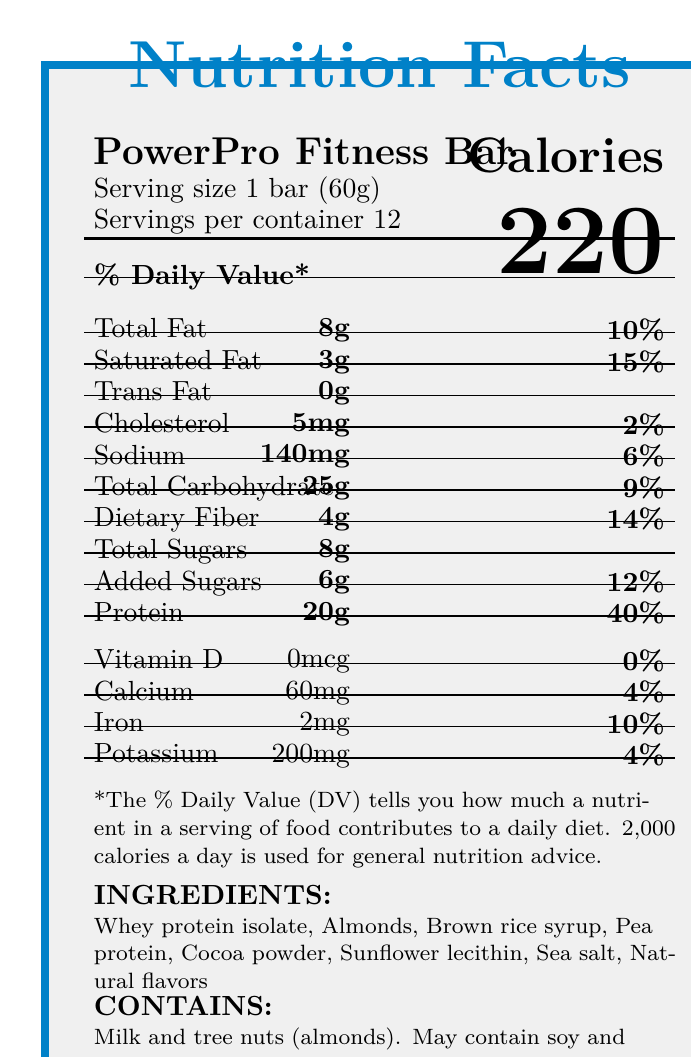what is the product name? The product name is located at the top of the document, under the title "Nutrition Facts".
Answer: PowerPro Fitness Bar how many servings are there per container? The information is found under the serving size and servings per container subheading.
Answer: 12 how many calories are in one serving? The calorie count per serving is prominently displayed on the right side of the document.
Answer: 220 what is the total amount of protein per serving? The protein content is listed in the main table under the "Protein" heading.
Answer: 20g what allergens does this product contain? The allergen information is found near the bottom under the CONTAINS section.
Answer: Milk and tree nuts (almonds) what is the daily value percentage for dietary fiber? This value is found under the "Dietary Fiber" row of the main table.
Answer: 14% what ingredients are used in this product? The ingredient list is located near the bottom of the document.
Answer: Whey protein isolate, Almonds, Brown rice syrup, Pea protein, Cocoa powder, Sunflower lecithin, Sea salt, Natural flavors does the product contain any artificial sweeteners? One of the health claims mentions that the product has "No artificial sweeteners".
Answer: No where should this product be stored? The storage instructions indicate that the product should be stored in a cool, dry place.
Answer: In a cool, dry place describe the main idea of this document. The document's main focus is to inform the consumer about the nutritional content, benefits, and storage of the PowerPro Fitness Bar.
Answer: The document provides detailed nutritional information about the PowerPro Fitness Bar, including serving size, calorie content, nutrient breakdown, ingredients, allergens, and storage instructions. what is the total carbohydrate content per serving? The total carbohydrate content is listed under "Total Carbohydrate" in the main table.
Answer: 25g what is the address of the manufacturer? The manufacturer’s address is found in the manufacturer info section.
Answer: 123 Fitness Way, Wellness City, CA 90210 which of the following is NOT an ingredient in the PowerPro Fitness Bar? A. Whey protein isolate B. Almonds C. Brown sugar D. Cocoa powder Brown sugar is not listed among the ingredients; the correct ingredients are whey protein isolate, almonds, brown rice syrup, pea protein, cocoa powder, sunflower lecithin, sea salt, and natural flavors.
Answer: C. Brown sugar what is the daily value percentage for saturated fat? A. 10% B. 15% C. 5% D. 20% The daily value percentage for saturated fat is listed as 15%, found next to the saturated fat amount in the main table.
Answer: B. 15% does the product have a significant amount of Vitamin D? The document shows that the amount of Vitamin D is 0mcg, which is 0% of the daily value.
Answer: No what is the total fat content per serving? The total fat content is listed under "Total Fat" in the main table.
Answer: 8g how much sodium is in the PowerPro Fitness Bar? Sodium content is listed in the main table under the "Sodium" row.
Answer: 140mg are there any health claims associated with this product? The document mentions health claims such as "Good source of protein", "High in fiber", and "No artificial sweeteners".
Answer: Yes who is the manufacturer of the product? The manufacturer info section states that the product is made by Health Boost Nutrition, LLC.
Answer: Health Boost Nutrition, LLC is this product suitable for someone with a peanut allergy? The document states that the product may contain peanuts, so further information is needed to determine its suitability.
Answer: Not enough information what is the website for the PowerPro Fitness Bar? The website information is located in the manufacturer info section.
Answer: www.powerprofitness.com 